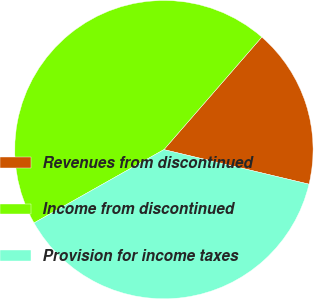Convert chart. <chart><loc_0><loc_0><loc_500><loc_500><pie_chart><fcel>Revenues from discontinued<fcel>Income from discontinued<fcel>Provision for income taxes<nl><fcel>17.33%<fcel>44.57%<fcel>38.1%<nl></chart> 